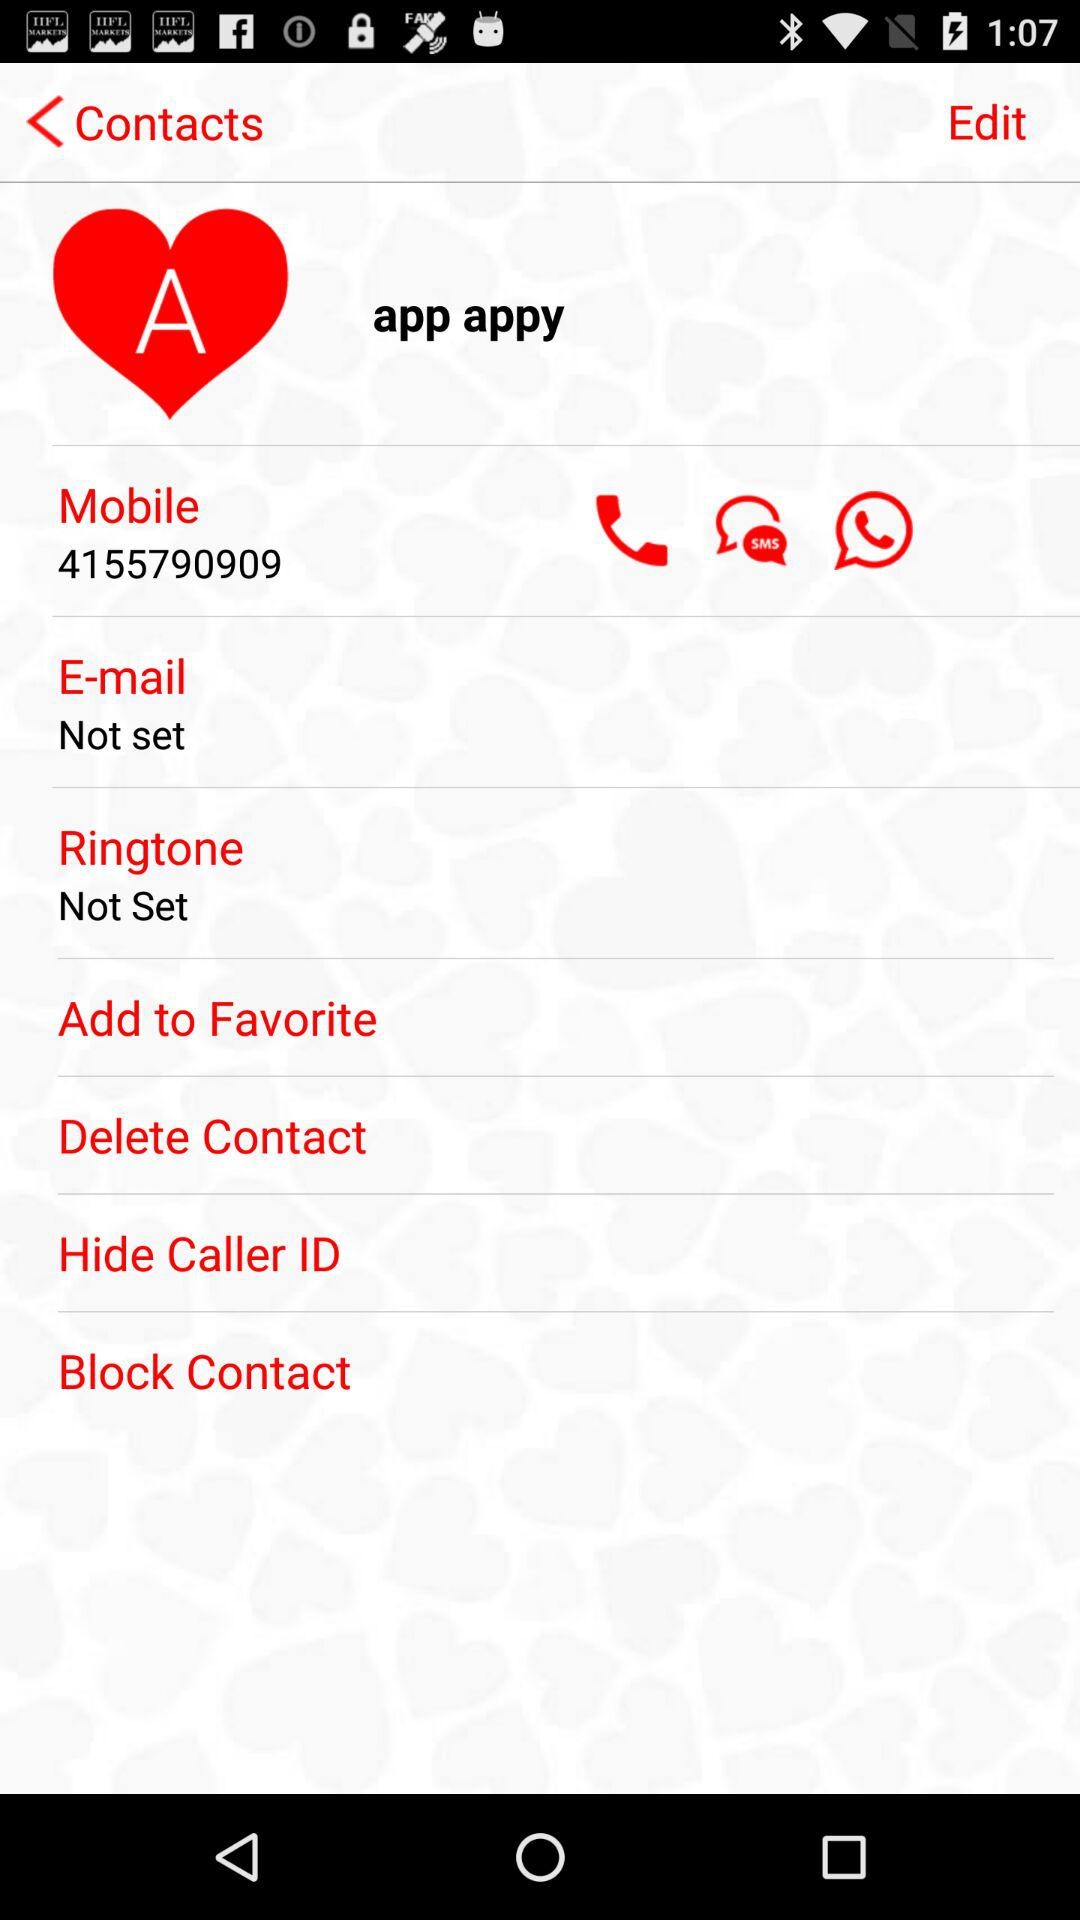What is the setting for the "Ringtone"? The setting for the "Ringtone" is "Not Set". 